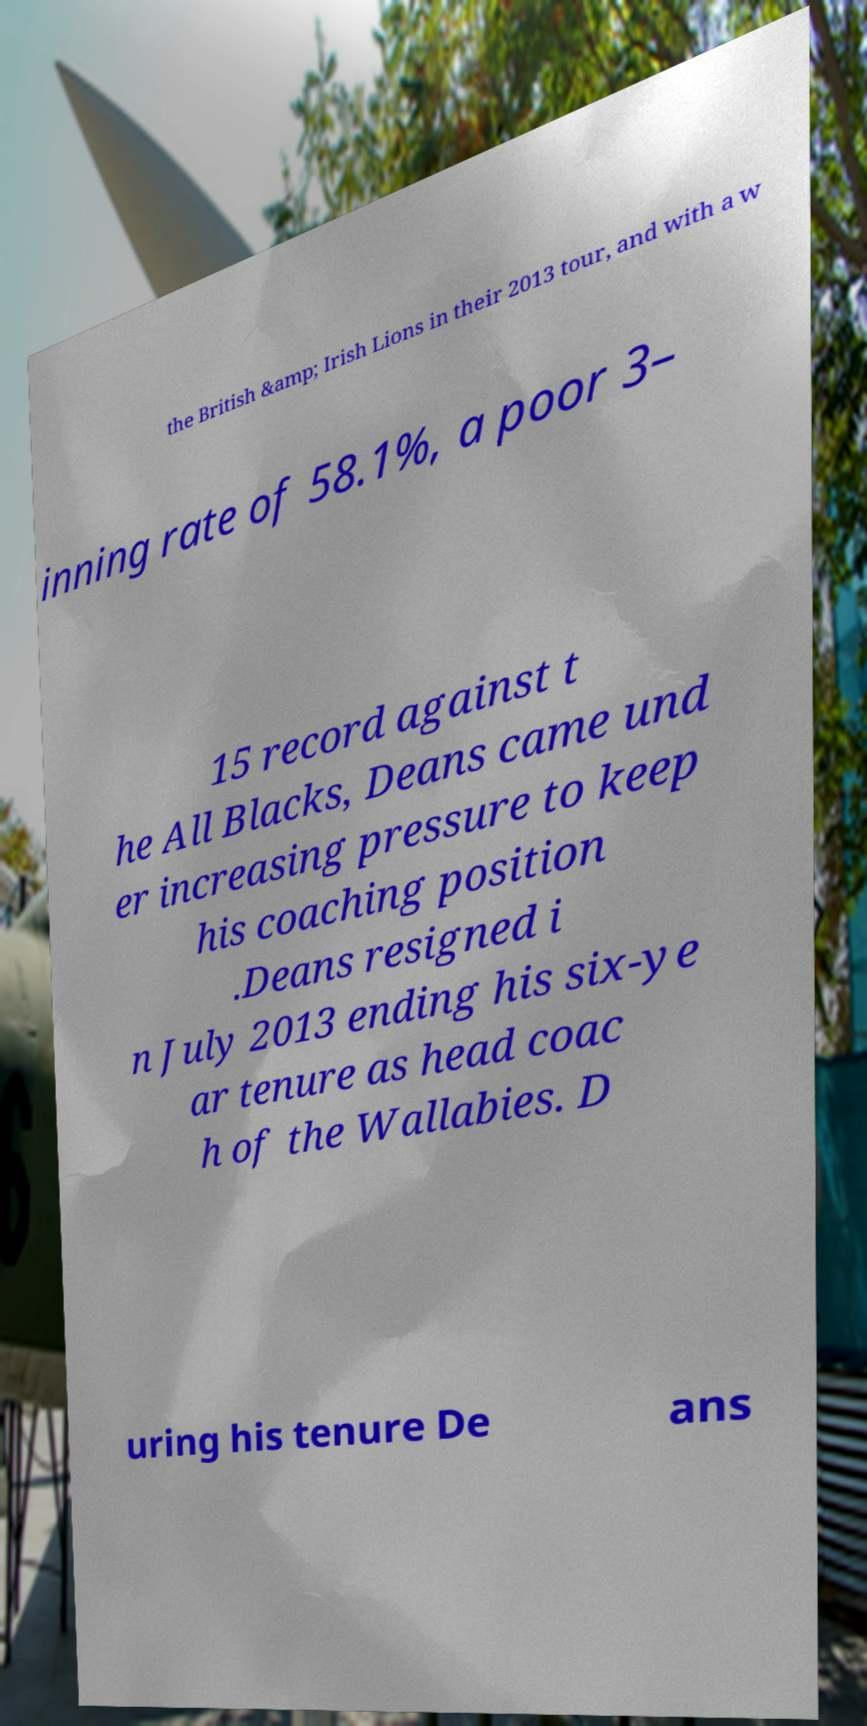Please identify and transcribe the text found in this image. the British &amp; Irish Lions in their 2013 tour, and with a w inning rate of 58.1%, a poor 3– 15 record against t he All Blacks, Deans came und er increasing pressure to keep his coaching position .Deans resigned i n July 2013 ending his six-ye ar tenure as head coac h of the Wallabies. D uring his tenure De ans 